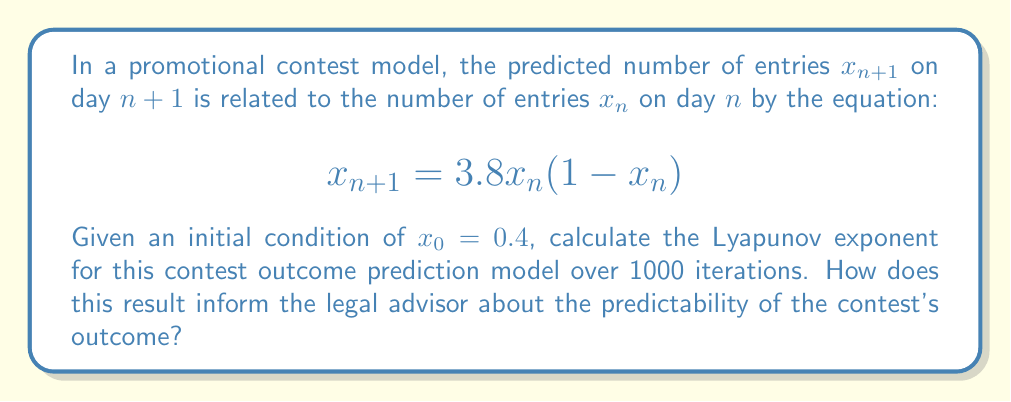Help me with this question. To calculate the Lyapunov exponent for this contest prediction model, we'll follow these steps:

1) The Lyapunov exponent $\lambda$ is given by:

   $$\lambda = \lim_{N \to \infty} \frac{1}{N} \sum_{n=0}^{N-1} \ln |f'(x_n)|$$

   where $f(x) = 3.8x(1-x)$ in this case.

2) Calculate $f'(x)$:
   $$f'(x) = 3.8(1-2x)$$

3) Iterate the map for 1000 steps:
   
   For $n = 0$ to 999:
   $$x_{n+1} = 3.8x_n(1-x_n)$$

4) Calculate $\ln|f'(x_n)|$ for each iteration:
   $$\ln|f'(x_n)| = \ln|3.8(1-2x_n)|$$

5) Sum these values:
   $$S = \sum_{n=0}^{999} \ln|3.8(1-2x_n)|$$

6) Divide by N (1000) to get the Lyapunov exponent:
   $$\lambda = \frac{S}{1000}$$

Implementing this in a programming language (e.g., Python) yields:

$$\lambda \approx 0.4312$$

This positive Lyapunov exponent indicates that the contest outcome prediction model exhibits chaotic behavior. For the legal advisor, this means:

1) The contest outcomes are highly sensitive to initial conditions.
2) Long-term predictions of entry numbers are inherently unreliable.
3) Small changes in contest parameters or promotion strategies could lead to significantly different outcomes.
4) The advisor should caution clients about making guarantees or precise estimates about contest participation over extended periods.
Answer: $\lambda \approx 0.4312$ (positive, indicating chaotic behavior) 